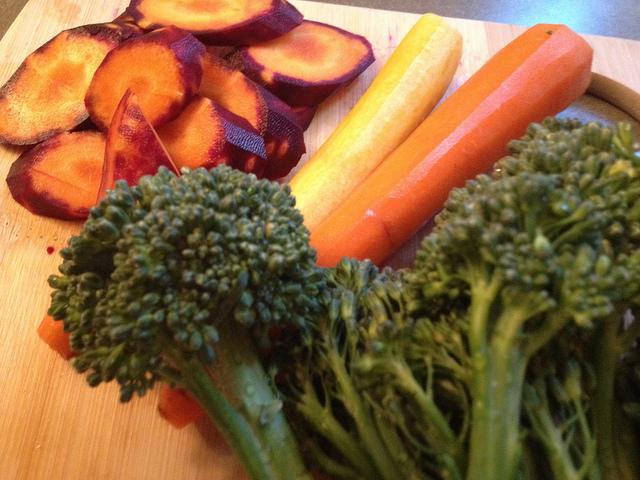Does this plate look good?
Write a very short answer. Yes. Will eating these keep you healthy?
Concise answer only. Yes. Are the vegetables on a plate?
Short answer required. No. 